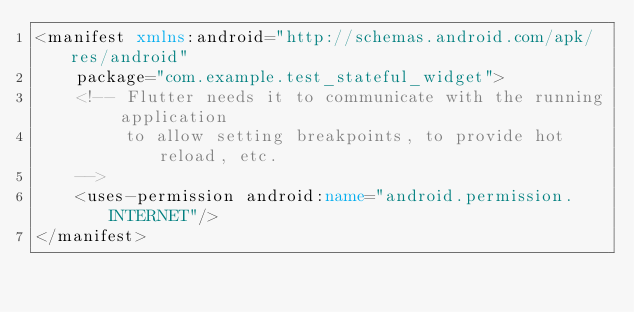Convert code to text. <code><loc_0><loc_0><loc_500><loc_500><_XML_><manifest xmlns:android="http://schemas.android.com/apk/res/android"
    package="com.example.test_stateful_widget">
    <!-- Flutter needs it to communicate with the running application
         to allow setting breakpoints, to provide hot reload, etc.
    -->
    <uses-permission android:name="android.permission.INTERNET"/>
</manifest>
</code> 